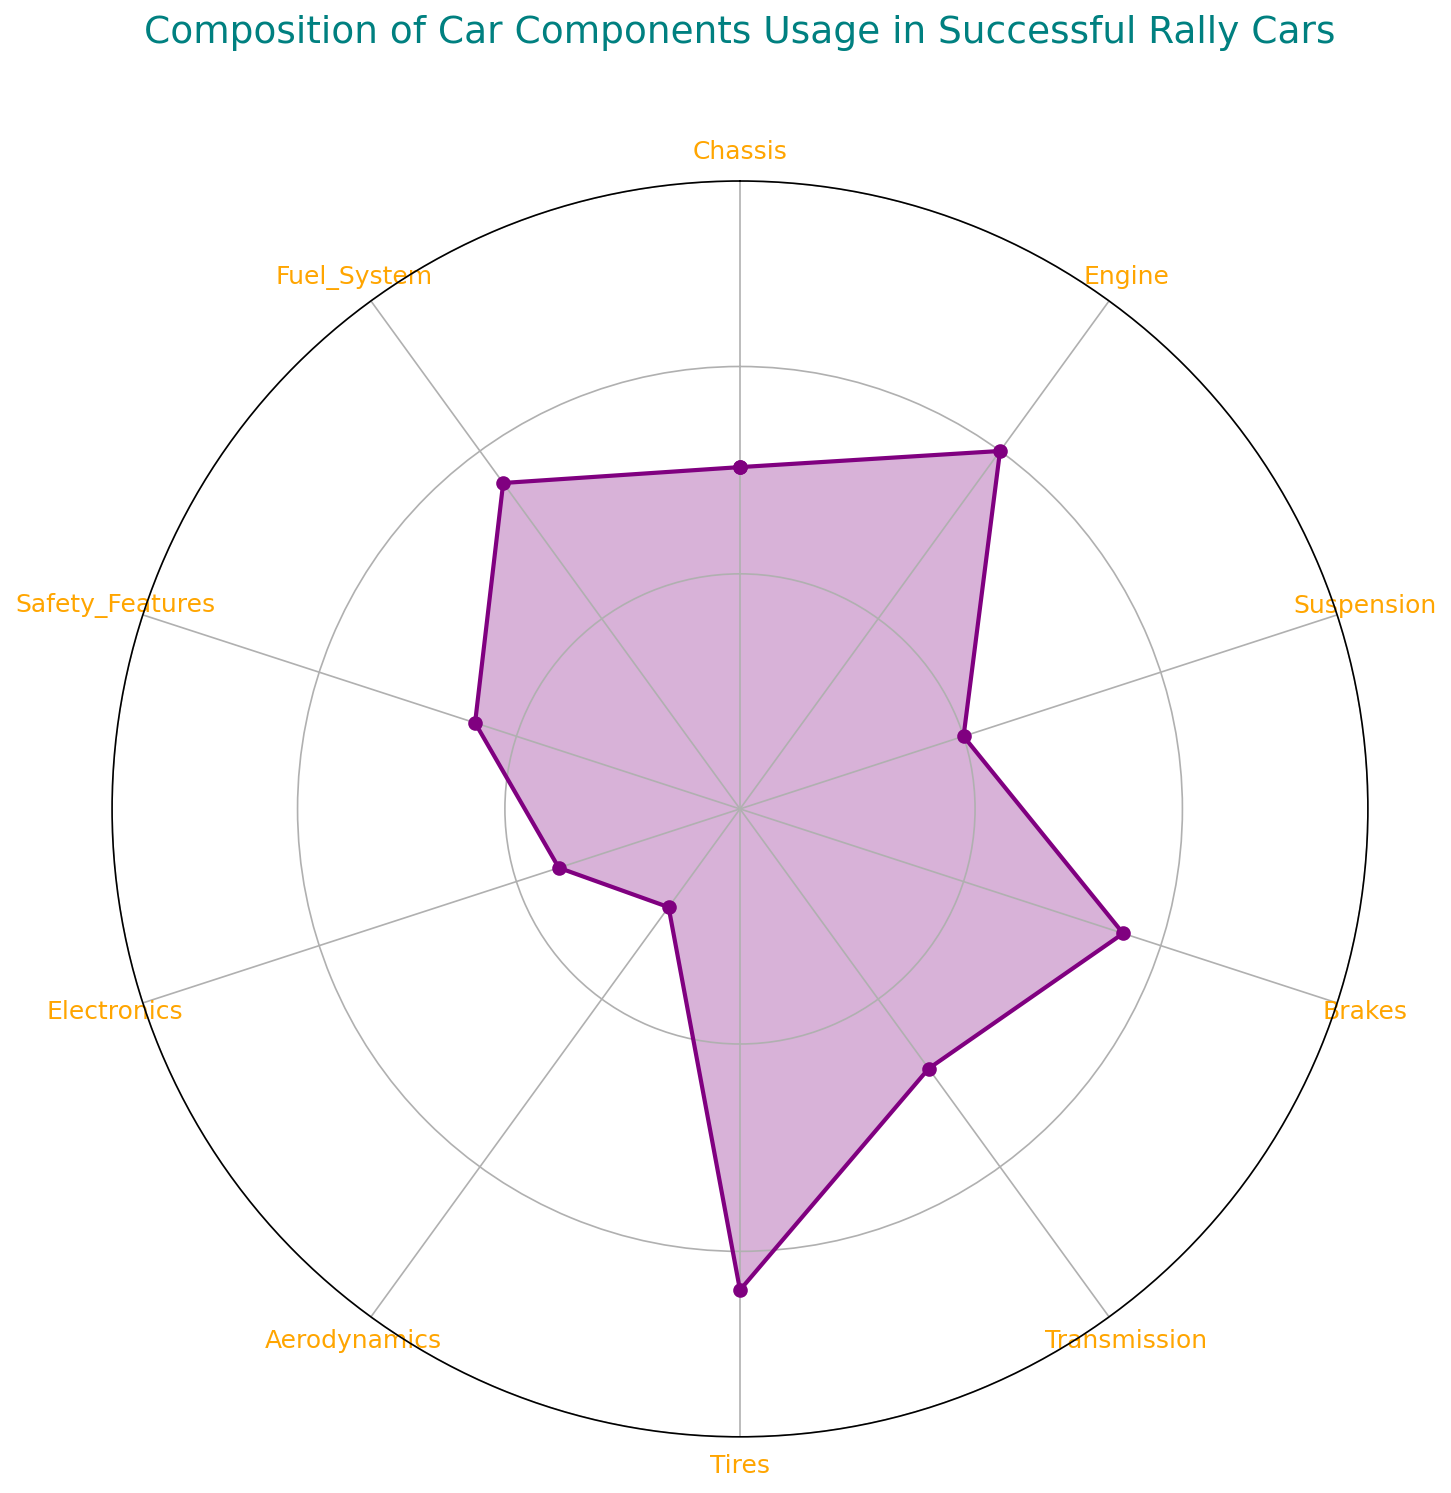What component has the highest usage percentage in successful rally cars? By looking at the radar chart, the component with the highest value on the radial axis is identified.
Answer: Tires What is the difference in usage percentage between the Suspension and the Electronics? Check the percentage values for both the Suspension (80%) and Electronics (78%), and subtract the lower value from the higher value: 80% - 78% = 2%.
Answer: 2% Which component shows the least usage percentage and what is its value? The component closest to the center of the radar chart represents the least usage percentage, which is Aerodynamics at 75%.
Answer: Aerodynamics, 75% How much greater is the usage percentage of the Engine compared to the Chassis? Identify the values for Engine (90%) and Chassis (85%), then calculate the difference: 90% - 85% = 5%.
Answer: 5% What's the average usage percentage of Brakes, Suspension, and Electronics? Add the percentages: 88% (Brakes) + 80% (Suspension) + 78% (Electronics) = 246%, then divide by 3: 246% / 3 = 82%.
Answer: 82% Between the Transmission and the Safety Features, which component has higher usage and by what amount? Identify the usage percentages for Transmission (84%) and Safety Features (82%), then find the difference: 84% - 82% = 2%.
Answer: Transmission, 2% What is the value of the second highest usage percentage, and which component does it represent? After identifying the highest usage (Tires at 92%), the second highest is Engine at 90%.
Answer: 90%, Engine Are the Brakes and Fuel System usage percentages equal? If so, what is their value? Observe the radar chart and see that both Brakes and Fuel System have usage percentages of 88%.
Answer: Yes, 88% What is the combined usage percentage of Chassis, Aerodynamics, and Safety Features? Sum up the percentages: 85% (Chassis) + 75% (Aerodynamics) + 82% (Safety Features) = 242%.
Answer: 242% Which component has a higher usage percentage: Brakes or Chassis? By comparing the values from the radar chart, Brakes have a usage percentage of 88% and Chassis have 85%. Brakes are higher.
Answer: Brakes 